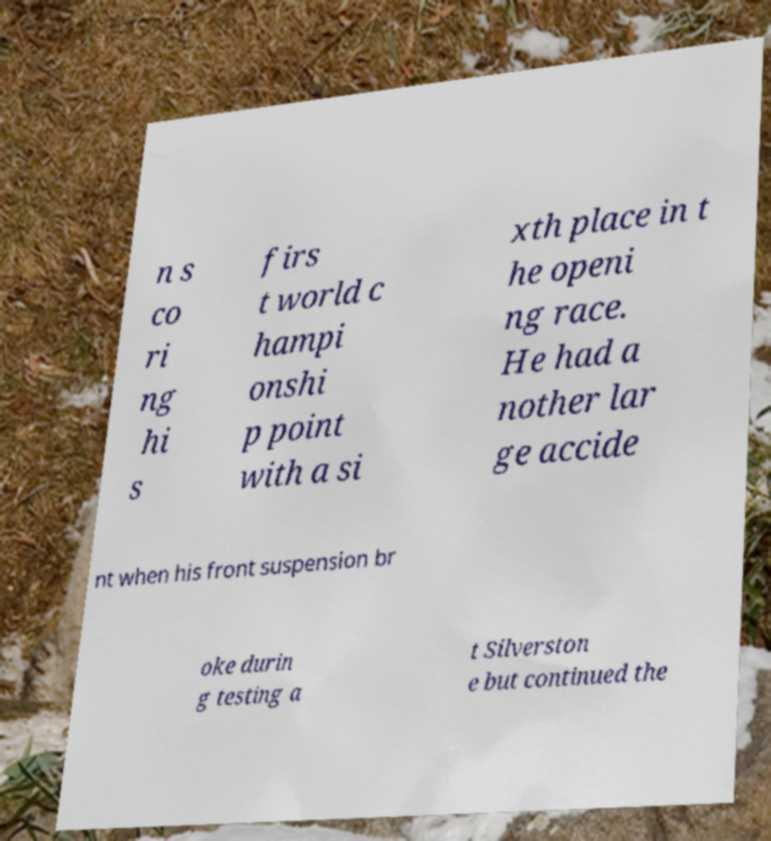Can you accurately transcribe the text from the provided image for me? n s co ri ng hi s firs t world c hampi onshi p point with a si xth place in t he openi ng race. He had a nother lar ge accide nt when his front suspension br oke durin g testing a t Silverston e but continued the 